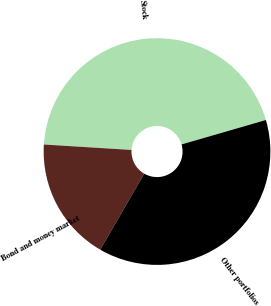Convert chart to OTSL. <chart><loc_0><loc_0><loc_500><loc_500><pie_chart><fcel>Stock<fcel>Bond and money market<fcel>Other portfolios<nl><fcel>44.53%<fcel>17.64%<fcel>37.84%<nl></chart> 